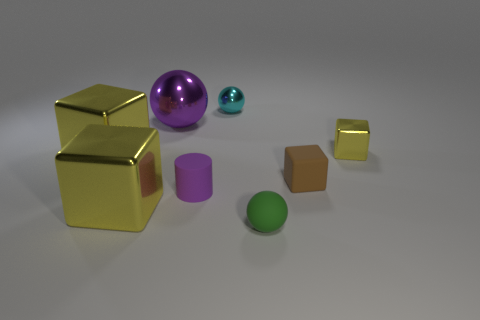Is the color of the big metal sphere the same as the small cylinder?
Give a very brief answer. Yes. What is the material of the ball that is the same color as the tiny matte cylinder?
Ensure brevity in your answer.  Metal. What size is the shiny thing that is the same color as the rubber cylinder?
Make the answer very short. Large. There is a matte thing on the left side of the matte ball; is it the same size as the shiny object in front of the cylinder?
Your answer should be compact. No. How many other things are the same shape as the tiny green matte object?
Ensure brevity in your answer.  2. What material is the yellow block that is right of the tiny cube on the left side of the small yellow metallic cube made of?
Provide a short and direct response. Metal. What number of matte objects are either big yellow objects or large balls?
Your answer should be compact. 0. There is a metallic sphere in front of the small cyan sphere; is there a yellow metal block that is on the left side of it?
Make the answer very short. Yes. What number of objects are either yellow metallic blocks that are left of the small cyan shiny ball or shiny balls in front of the tiny cyan metal thing?
Your answer should be compact. 3. Is there any other thing that has the same color as the cylinder?
Your response must be concise. Yes. 